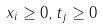Convert formula to latex. <formula><loc_0><loc_0><loc_500><loc_500>x _ { i } \geq 0 , t _ { j } \geq 0</formula> 